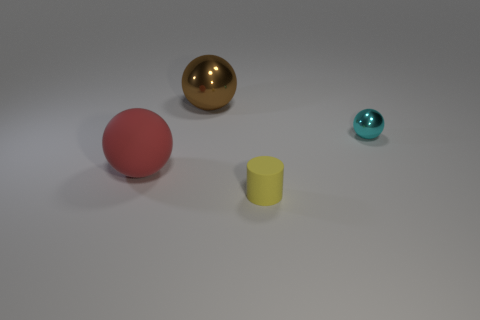Subtract all red matte spheres. How many spheres are left? 2 Subtract all cylinders. How many objects are left? 3 Subtract all purple spheres. How many blue cylinders are left? 0 Subtract all cyan shiny objects. Subtract all rubber spheres. How many objects are left? 2 Add 4 rubber things. How many rubber things are left? 6 Add 1 cyan things. How many cyan things exist? 2 Add 2 small green cylinders. How many objects exist? 6 Subtract all brown spheres. How many spheres are left? 2 Subtract 0 yellow cubes. How many objects are left? 4 Subtract all blue spheres. Subtract all red blocks. How many spheres are left? 3 